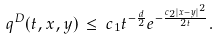Convert formula to latex. <formula><loc_0><loc_0><loc_500><loc_500>\, q ^ { D } ( t , x , y ) \, \leq \, c _ { 1 } t ^ { - \frac { d } { 2 } } e ^ { - \frac { c _ { 2 } | x - y | ^ { 2 } } { 2 t } } .</formula> 